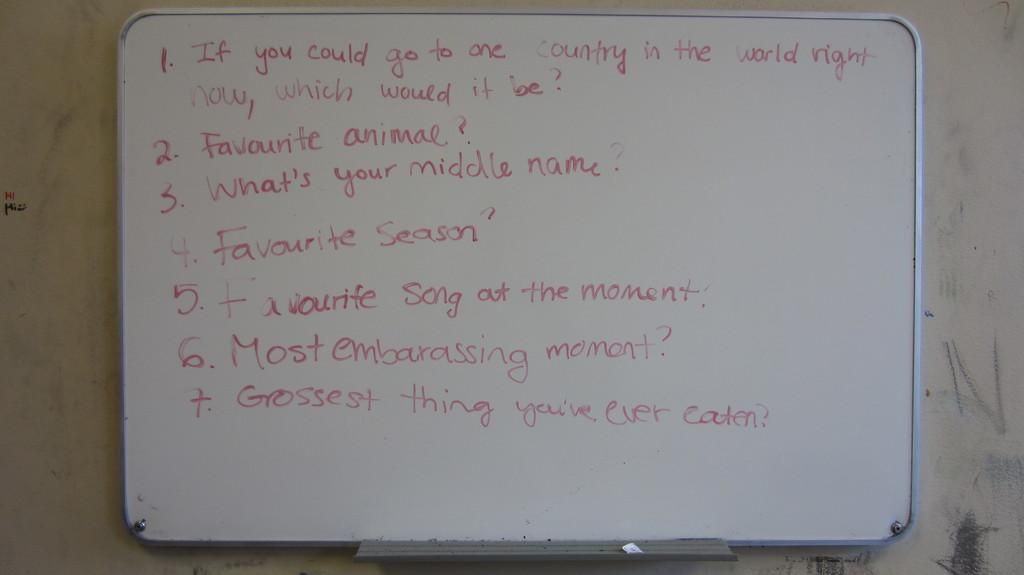<image>
Summarize the visual content of the image. the word most that is next to a number 6 